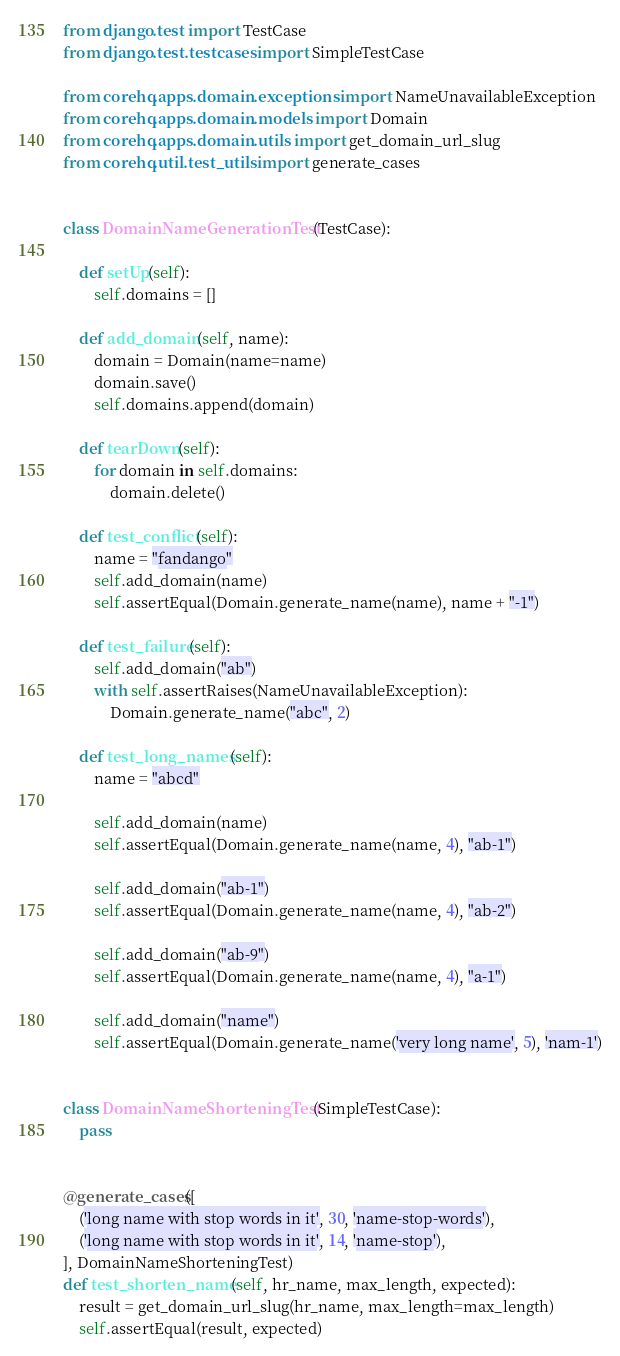Convert code to text. <code><loc_0><loc_0><loc_500><loc_500><_Python_>from django.test import TestCase
from django.test.testcases import SimpleTestCase

from corehq.apps.domain.exceptions import NameUnavailableException
from corehq.apps.domain.models import Domain
from corehq.apps.domain.utils import get_domain_url_slug
from corehq.util.test_utils import generate_cases


class DomainNameGenerationTest(TestCase):

    def setUp(self):
        self.domains = []

    def add_domain(self, name):
        domain = Domain(name=name)
        domain.save()
        self.domains.append(domain)

    def tearDown(self):
        for domain in self.domains:
            domain.delete()

    def test_conflict(self):
        name = "fandango"
        self.add_domain(name)
        self.assertEqual(Domain.generate_name(name), name + "-1")

    def test_failure(self):
        self.add_domain("ab")
        with self.assertRaises(NameUnavailableException):
            Domain.generate_name("abc", 2)

    def test_long_names(self):
        name = "abcd"

        self.add_domain(name)
        self.assertEqual(Domain.generate_name(name, 4), "ab-1")

        self.add_domain("ab-1")
        self.assertEqual(Domain.generate_name(name, 4), "ab-2")

        self.add_domain("ab-9")
        self.assertEqual(Domain.generate_name(name, 4), "a-1")

        self.add_domain("name")
        self.assertEqual(Domain.generate_name('very long name', 5), 'nam-1')


class DomainNameShorteningTest(SimpleTestCase):
    pass


@generate_cases([
    ('long name with stop words in it', 30, 'name-stop-words'),
    ('long name with stop words in it', 14, 'name-stop'),
], DomainNameShorteningTest)
def test_shorten_name(self, hr_name, max_length, expected):
    result = get_domain_url_slug(hr_name, max_length=max_length)
    self.assertEqual(result, expected)
</code> 